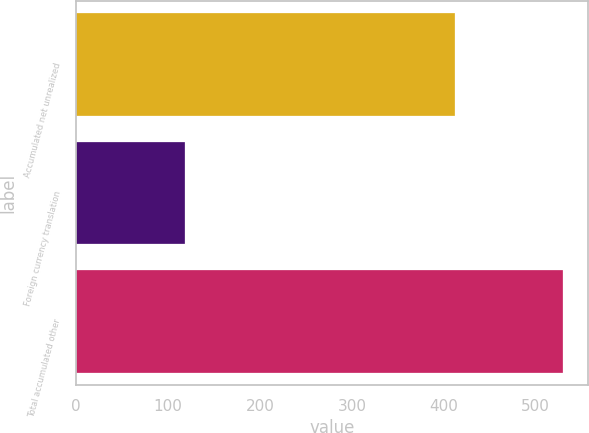<chart> <loc_0><loc_0><loc_500><loc_500><bar_chart><fcel>Accumulated net unrealized<fcel>Foreign currency translation<fcel>Total accumulated other<nl><fcel>412<fcel>118<fcel>530<nl></chart> 